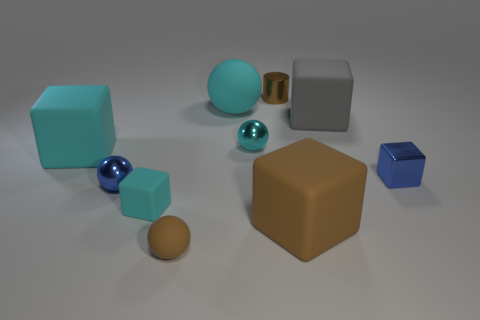Is the shape of the small brown object on the left side of the big cyan matte ball the same as the small blue thing on the left side of the metal block?
Your answer should be very brief. Yes. Is there a big brown matte cube?
Offer a terse response. Yes. There is another small rubber thing that is the same shape as the gray thing; what is its color?
Offer a very short reply. Cyan. There is a metal cylinder that is the same size as the blue cube; what color is it?
Provide a short and direct response. Brown. Do the tiny brown cylinder and the tiny cyan sphere have the same material?
Ensure brevity in your answer.  Yes. What number of tiny matte things are the same color as the small cylinder?
Ensure brevity in your answer.  1. Do the small shiny cube and the tiny matte sphere have the same color?
Give a very brief answer. No. What is the material of the brown object that is left of the tiny cylinder?
Give a very brief answer. Rubber. How many big things are either rubber spheres or blue cubes?
Offer a very short reply. 1. There is a block that is the same color as the small shiny cylinder; what is its material?
Offer a very short reply. Rubber. 